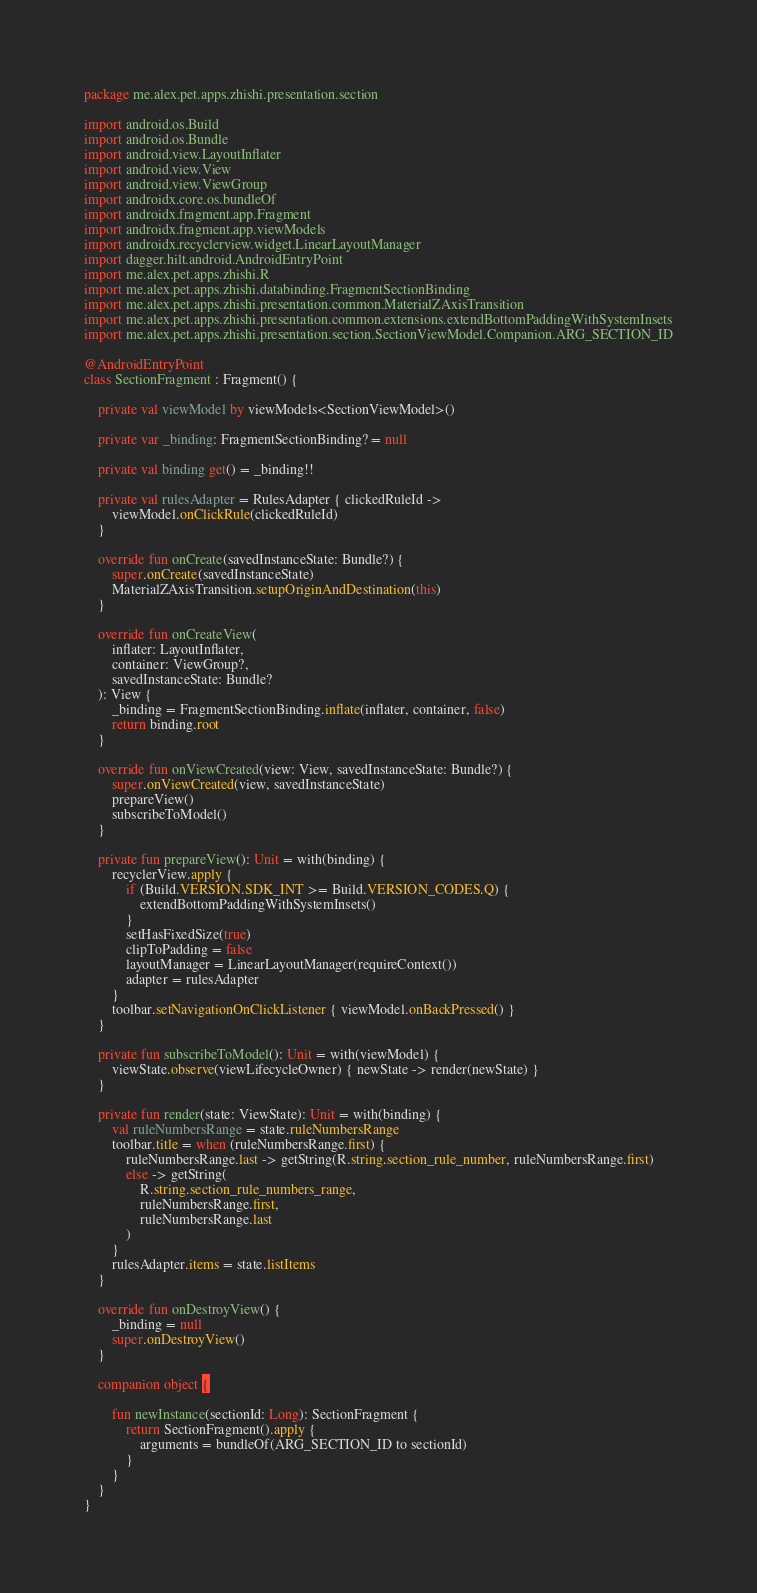Convert code to text. <code><loc_0><loc_0><loc_500><loc_500><_Kotlin_>package me.alex.pet.apps.zhishi.presentation.section

import android.os.Build
import android.os.Bundle
import android.view.LayoutInflater
import android.view.View
import android.view.ViewGroup
import androidx.core.os.bundleOf
import androidx.fragment.app.Fragment
import androidx.fragment.app.viewModels
import androidx.recyclerview.widget.LinearLayoutManager
import dagger.hilt.android.AndroidEntryPoint
import me.alex.pet.apps.zhishi.R
import me.alex.pet.apps.zhishi.databinding.FragmentSectionBinding
import me.alex.pet.apps.zhishi.presentation.common.MaterialZAxisTransition
import me.alex.pet.apps.zhishi.presentation.common.extensions.extendBottomPaddingWithSystemInsets
import me.alex.pet.apps.zhishi.presentation.section.SectionViewModel.Companion.ARG_SECTION_ID

@AndroidEntryPoint
class SectionFragment : Fragment() {

    private val viewModel by viewModels<SectionViewModel>()

    private var _binding: FragmentSectionBinding? = null

    private val binding get() = _binding!!

    private val rulesAdapter = RulesAdapter { clickedRuleId ->
        viewModel.onClickRule(clickedRuleId)
    }

    override fun onCreate(savedInstanceState: Bundle?) {
        super.onCreate(savedInstanceState)
        MaterialZAxisTransition.setupOriginAndDestination(this)
    }

    override fun onCreateView(
        inflater: LayoutInflater,
        container: ViewGroup?,
        savedInstanceState: Bundle?
    ): View {
        _binding = FragmentSectionBinding.inflate(inflater, container, false)
        return binding.root
    }

    override fun onViewCreated(view: View, savedInstanceState: Bundle?) {
        super.onViewCreated(view, savedInstanceState)
        prepareView()
        subscribeToModel()
    }

    private fun prepareView(): Unit = with(binding) {
        recyclerView.apply {
            if (Build.VERSION.SDK_INT >= Build.VERSION_CODES.Q) {
                extendBottomPaddingWithSystemInsets()
            }
            setHasFixedSize(true)
            clipToPadding = false
            layoutManager = LinearLayoutManager(requireContext())
            adapter = rulesAdapter
        }
        toolbar.setNavigationOnClickListener { viewModel.onBackPressed() }
    }

    private fun subscribeToModel(): Unit = with(viewModel) {
        viewState.observe(viewLifecycleOwner) { newState -> render(newState) }
    }

    private fun render(state: ViewState): Unit = with(binding) {
        val ruleNumbersRange = state.ruleNumbersRange
        toolbar.title = when (ruleNumbersRange.first) {
            ruleNumbersRange.last -> getString(R.string.section_rule_number, ruleNumbersRange.first)
            else -> getString(
                R.string.section_rule_numbers_range,
                ruleNumbersRange.first,
                ruleNumbersRange.last
            )
        }
        rulesAdapter.items = state.listItems
    }

    override fun onDestroyView() {
        _binding = null
        super.onDestroyView()
    }

    companion object {

        fun newInstance(sectionId: Long): SectionFragment {
            return SectionFragment().apply {
                arguments = bundleOf(ARG_SECTION_ID to sectionId)
            }
        }
    }
}</code> 